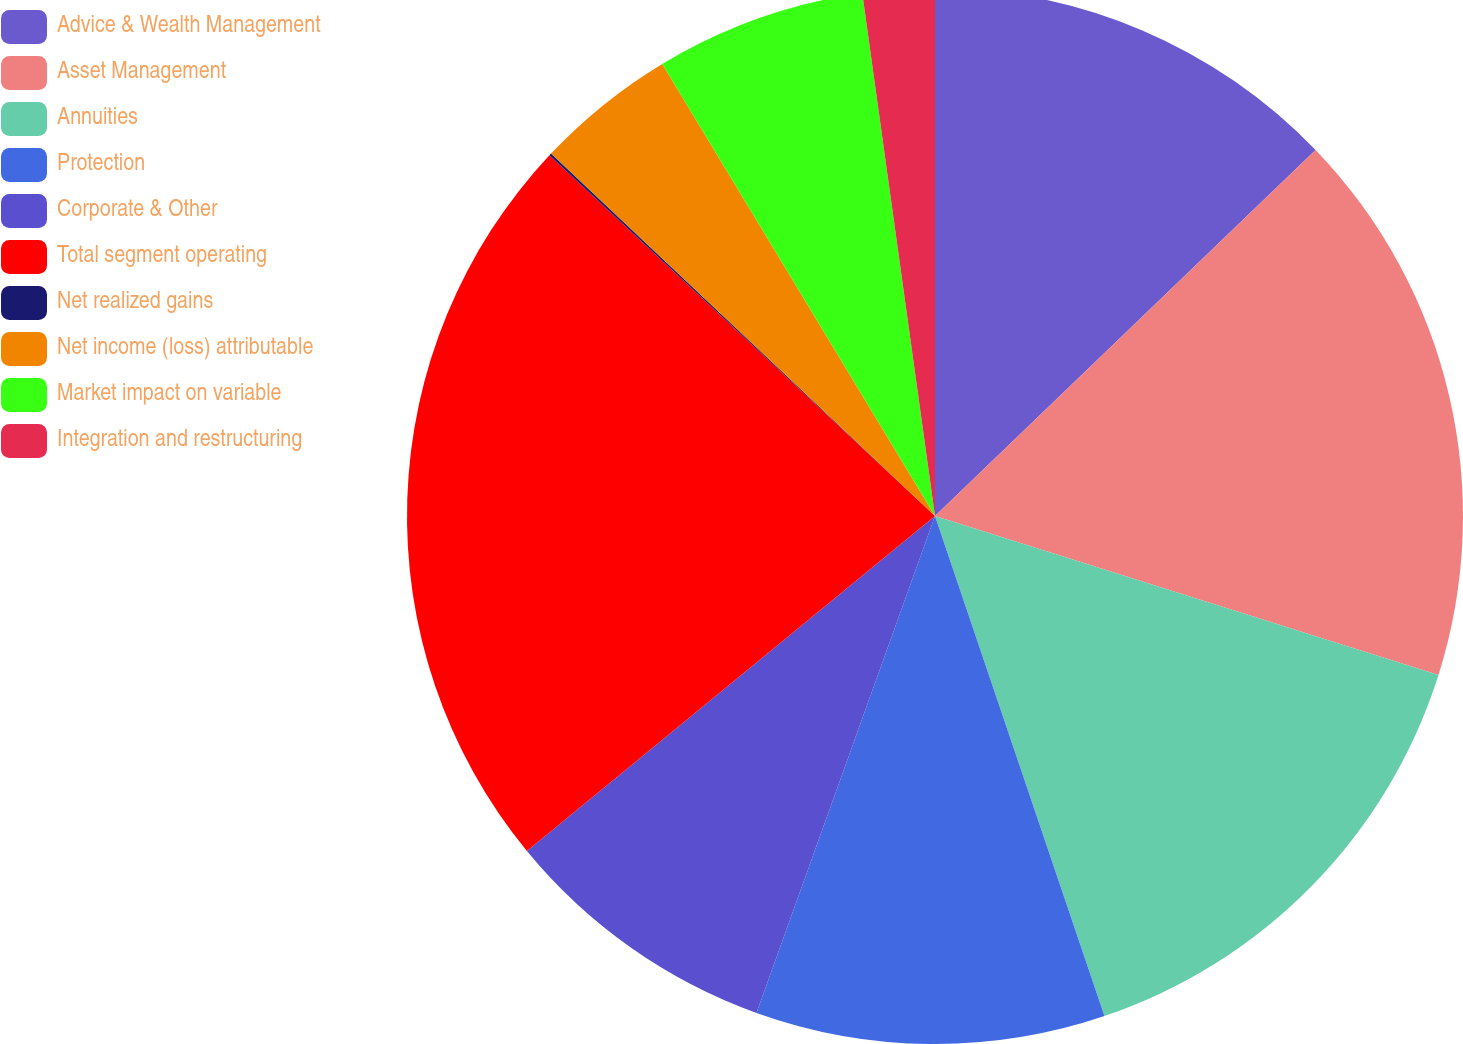Convert chart to OTSL. <chart><loc_0><loc_0><loc_500><loc_500><pie_chart><fcel>Advice & Wealth Management<fcel>Asset Management<fcel>Annuities<fcel>Protection<fcel>Corporate & Other<fcel>Total segment operating<fcel>Net realized gains<fcel>Net income (loss) attributable<fcel>Market impact on variable<fcel>Integration and restructuring<nl><fcel>12.81%<fcel>17.06%<fcel>14.93%<fcel>10.69%<fcel>8.57%<fcel>22.91%<fcel>0.07%<fcel>4.32%<fcel>6.44%<fcel>2.2%<nl></chart> 